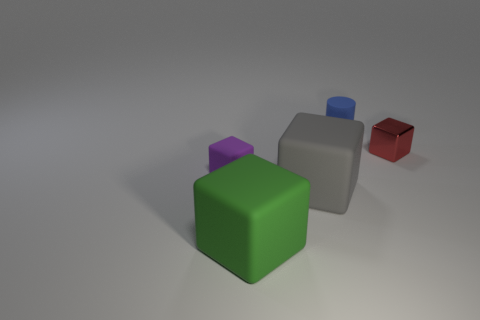What could be the possible use or significance of these cubes in the context they are presented? The cubes might symbolize a variety of concepts depending on the context. They could represent data visualization, where each cube stands for a different category or value in a dataset. Alternatively, they might be part of a learning or puzzle game, challenging individuals to recognize patterns or sequences. The arrangement and distinct colors could also suggest a focus on color theory or design principles in an educational setting. 